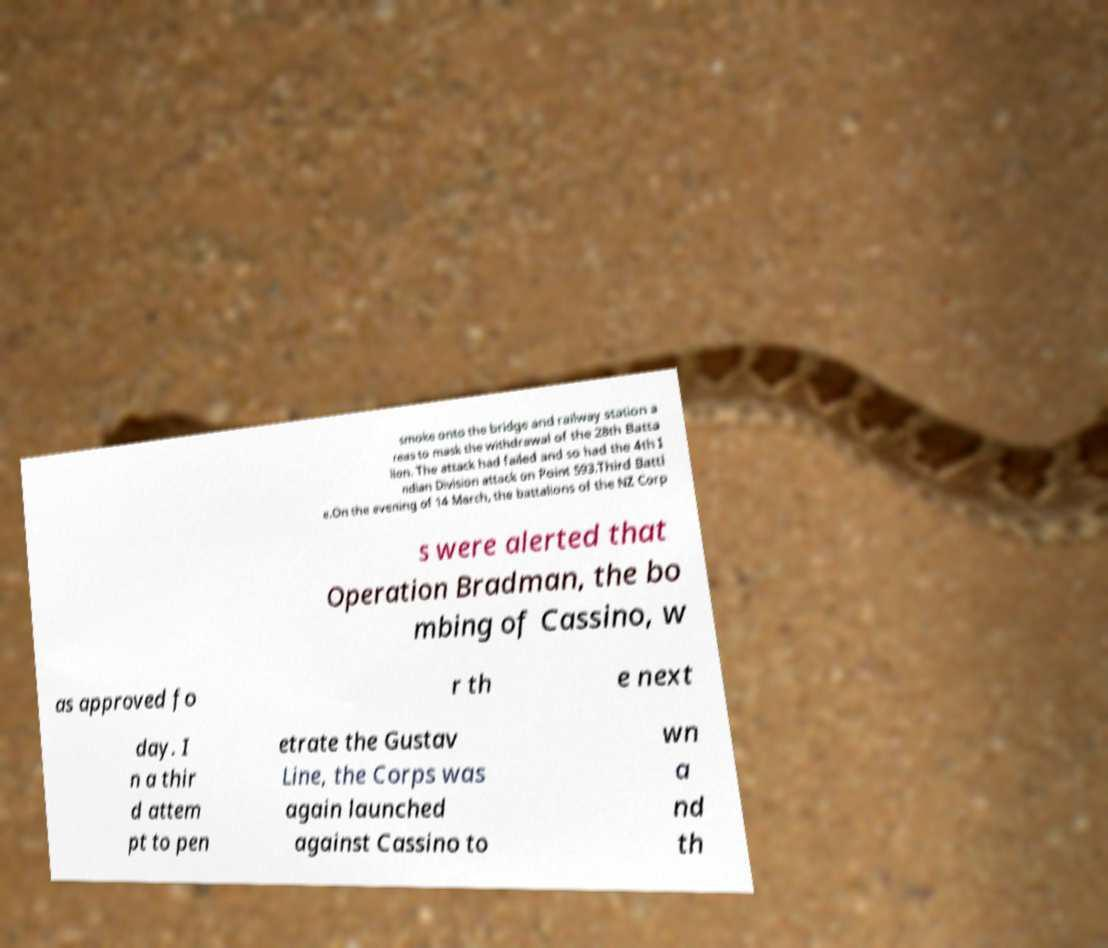Please identify and transcribe the text found in this image. smoke onto the bridge and railway station a reas to mask the withdrawal of the 28th Batta lion. The attack had failed and so had the 4th I ndian Division attack on Point 593.Third Battl e.On the evening of 14 March, the battalions of the NZ Corp s were alerted that Operation Bradman, the bo mbing of Cassino, w as approved fo r th e next day. I n a thir d attem pt to pen etrate the Gustav Line, the Corps was again launched against Cassino to wn a nd th 